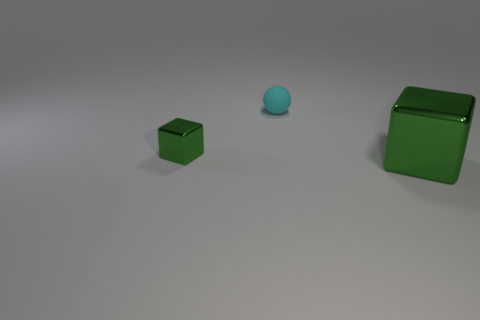How many objects are there in total within this image? In the image, there are three objects in total. A small green cube, a larger green cube, and a small blue sphere. 